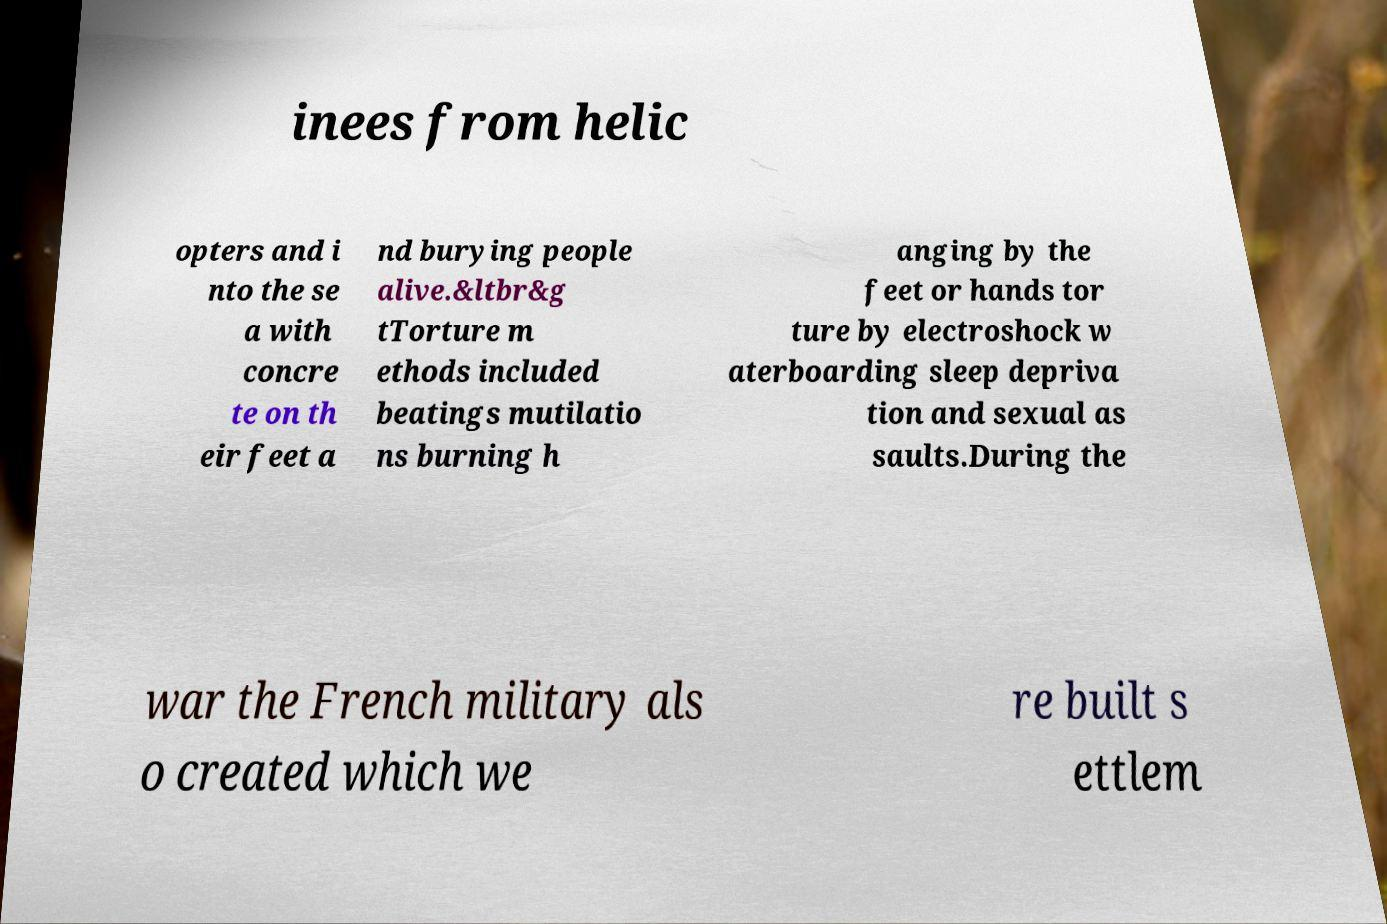Can you accurately transcribe the text from the provided image for me? inees from helic opters and i nto the se a with concre te on th eir feet a nd burying people alive.&ltbr&g tTorture m ethods included beatings mutilatio ns burning h anging by the feet or hands tor ture by electroshock w aterboarding sleep depriva tion and sexual as saults.During the war the French military als o created which we re built s ettlem 